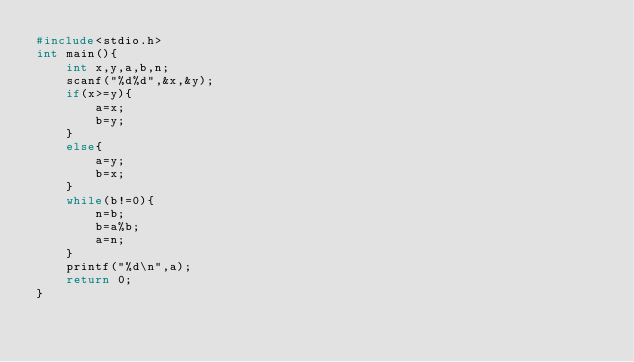<code> <loc_0><loc_0><loc_500><loc_500><_C_>#include<stdio.h>
int main(){
    int x,y,a,b,n;
    scanf("%d%d",&x,&y);
    if(x>=y){
        a=x;
        b=y;
    }
    else{
        a=y;
        b=x;
    }
    while(b!=0){
        n=b;
        b=a%b;
        a=n;
    }
    printf("%d\n",a);
    return 0;
}
</code> 